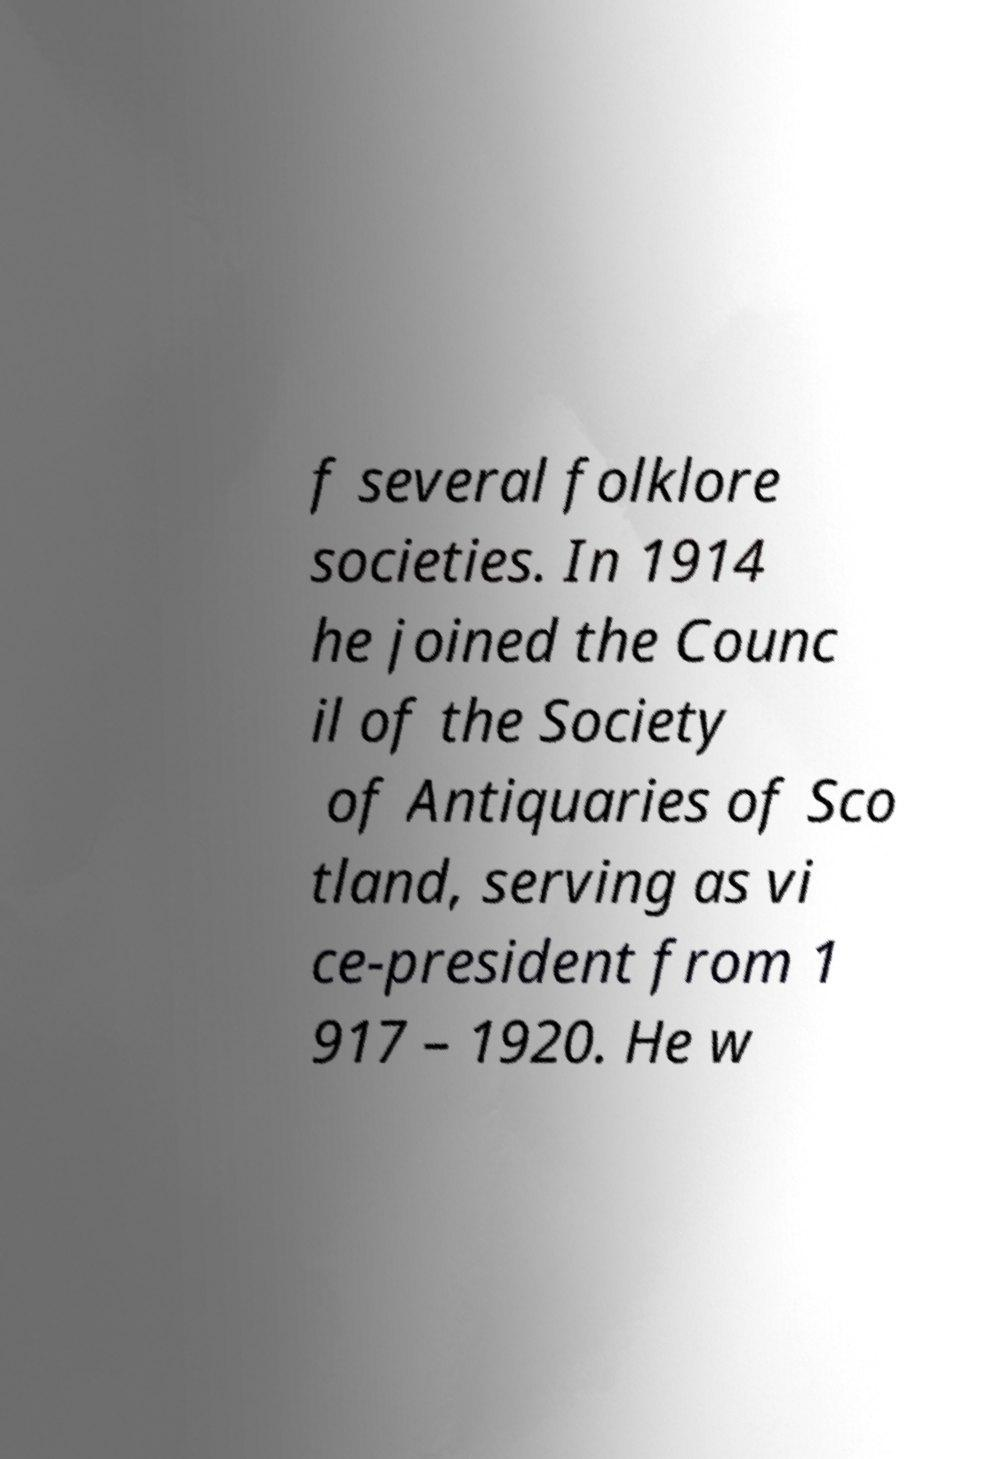Please identify and transcribe the text found in this image. f several folklore societies. In 1914 he joined the Counc il of the Society of Antiquaries of Sco tland, serving as vi ce-president from 1 917 – 1920. He w 